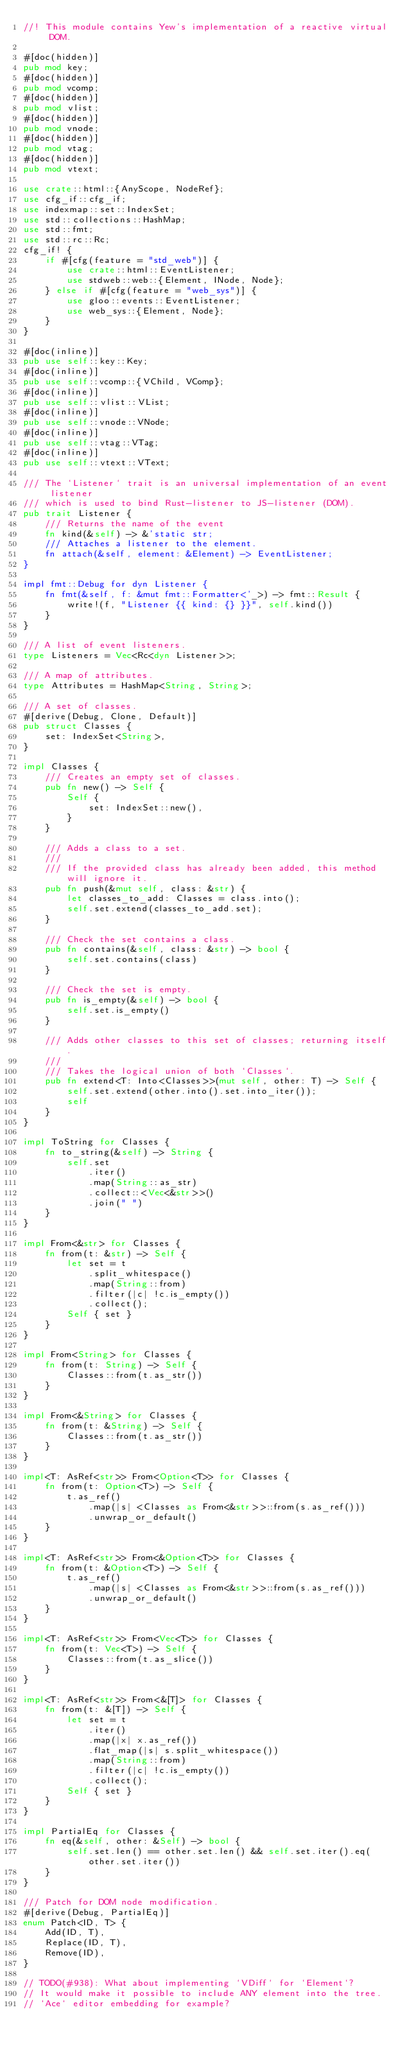<code> <loc_0><loc_0><loc_500><loc_500><_Rust_>//! This module contains Yew's implementation of a reactive virtual DOM.

#[doc(hidden)]
pub mod key;
#[doc(hidden)]
pub mod vcomp;
#[doc(hidden)]
pub mod vlist;
#[doc(hidden)]
pub mod vnode;
#[doc(hidden)]
pub mod vtag;
#[doc(hidden)]
pub mod vtext;

use crate::html::{AnyScope, NodeRef};
use cfg_if::cfg_if;
use indexmap::set::IndexSet;
use std::collections::HashMap;
use std::fmt;
use std::rc::Rc;
cfg_if! {
    if #[cfg(feature = "std_web")] {
        use crate::html::EventListener;
        use stdweb::web::{Element, INode, Node};
    } else if #[cfg(feature = "web_sys")] {
        use gloo::events::EventListener;
        use web_sys::{Element, Node};
    }
}

#[doc(inline)]
pub use self::key::Key;
#[doc(inline)]
pub use self::vcomp::{VChild, VComp};
#[doc(inline)]
pub use self::vlist::VList;
#[doc(inline)]
pub use self::vnode::VNode;
#[doc(inline)]
pub use self::vtag::VTag;
#[doc(inline)]
pub use self::vtext::VText;

/// The `Listener` trait is an universal implementation of an event listener
/// which is used to bind Rust-listener to JS-listener (DOM).
pub trait Listener {
    /// Returns the name of the event
    fn kind(&self) -> &'static str;
    /// Attaches a listener to the element.
    fn attach(&self, element: &Element) -> EventListener;
}

impl fmt::Debug for dyn Listener {
    fn fmt(&self, f: &mut fmt::Formatter<'_>) -> fmt::Result {
        write!(f, "Listener {{ kind: {} }}", self.kind())
    }
}

/// A list of event listeners.
type Listeners = Vec<Rc<dyn Listener>>;

/// A map of attributes.
type Attributes = HashMap<String, String>;

/// A set of classes.
#[derive(Debug, Clone, Default)]
pub struct Classes {
    set: IndexSet<String>,
}

impl Classes {
    /// Creates an empty set of classes.
    pub fn new() -> Self {
        Self {
            set: IndexSet::new(),
        }
    }

    /// Adds a class to a set.
    ///
    /// If the provided class has already been added, this method will ignore it.
    pub fn push(&mut self, class: &str) {
        let classes_to_add: Classes = class.into();
        self.set.extend(classes_to_add.set);
    }

    /// Check the set contains a class.
    pub fn contains(&self, class: &str) -> bool {
        self.set.contains(class)
    }

    /// Check the set is empty.
    pub fn is_empty(&self) -> bool {
        self.set.is_empty()
    }

    /// Adds other classes to this set of classes; returning itself.
    ///
    /// Takes the logical union of both `Classes`.
    pub fn extend<T: Into<Classes>>(mut self, other: T) -> Self {
        self.set.extend(other.into().set.into_iter());
        self
    }
}

impl ToString for Classes {
    fn to_string(&self) -> String {
        self.set
            .iter()
            .map(String::as_str)
            .collect::<Vec<&str>>()
            .join(" ")
    }
}

impl From<&str> for Classes {
    fn from(t: &str) -> Self {
        let set = t
            .split_whitespace()
            .map(String::from)
            .filter(|c| !c.is_empty())
            .collect();
        Self { set }
    }
}

impl From<String> for Classes {
    fn from(t: String) -> Self {
        Classes::from(t.as_str())
    }
}

impl From<&String> for Classes {
    fn from(t: &String) -> Self {
        Classes::from(t.as_str())
    }
}

impl<T: AsRef<str>> From<Option<T>> for Classes {
    fn from(t: Option<T>) -> Self {
        t.as_ref()
            .map(|s| <Classes as From<&str>>::from(s.as_ref()))
            .unwrap_or_default()
    }
}

impl<T: AsRef<str>> From<&Option<T>> for Classes {
    fn from(t: &Option<T>) -> Self {
        t.as_ref()
            .map(|s| <Classes as From<&str>>::from(s.as_ref()))
            .unwrap_or_default()
    }
}

impl<T: AsRef<str>> From<Vec<T>> for Classes {
    fn from(t: Vec<T>) -> Self {
        Classes::from(t.as_slice())
    }
}

impl<T: AsRef<str>> From<&[T]> for Classes {
    fn from(t: &[T]) -> Self {
        let set = t
            .iter()
            .map(|x| x.as_ref())
            .flat_map(|s| s.split_whitespace())
            .map(String::from)
            .filter(|c| !c.is_empty())
            .collect();
        Self { set }
    }
}

impl PartialEq for Classes {
    fn eq(&self, other: &Self) -> bool {
        self.set.len() == other.set.len() && self.set.iter().eq(other.set.iter())
    }
}

/// Patch for DOM node modification.
#[derive(Debug, PartialEq)]
enum Patch<ID, T> {
    Add(ID, T),
    Replace(ID, T),
    Remove(ID),
}

// TODO(#938): What about implementing `VDiff` for `Element`?
// It would make it possible to include ANY element into the tree.
// `Ace` editor embedding for example?
</code> 